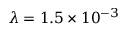Convert formula to latex. <formula><loc_0><loc_0><loc_500><loc_500>\lambda = 1 . 5 \times 1 0 ^ { - 3 }</formula> 